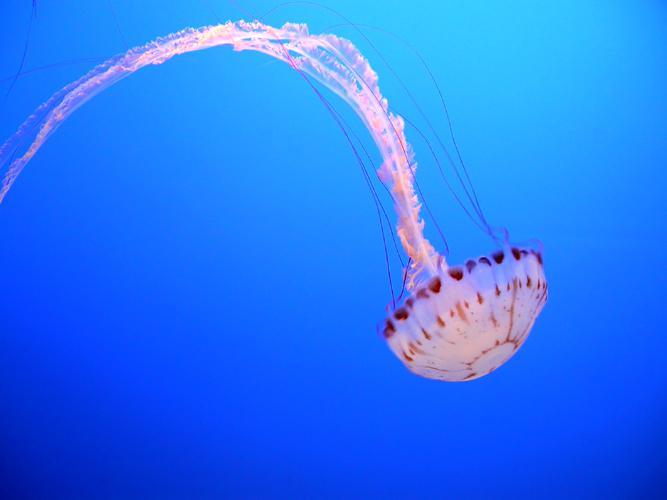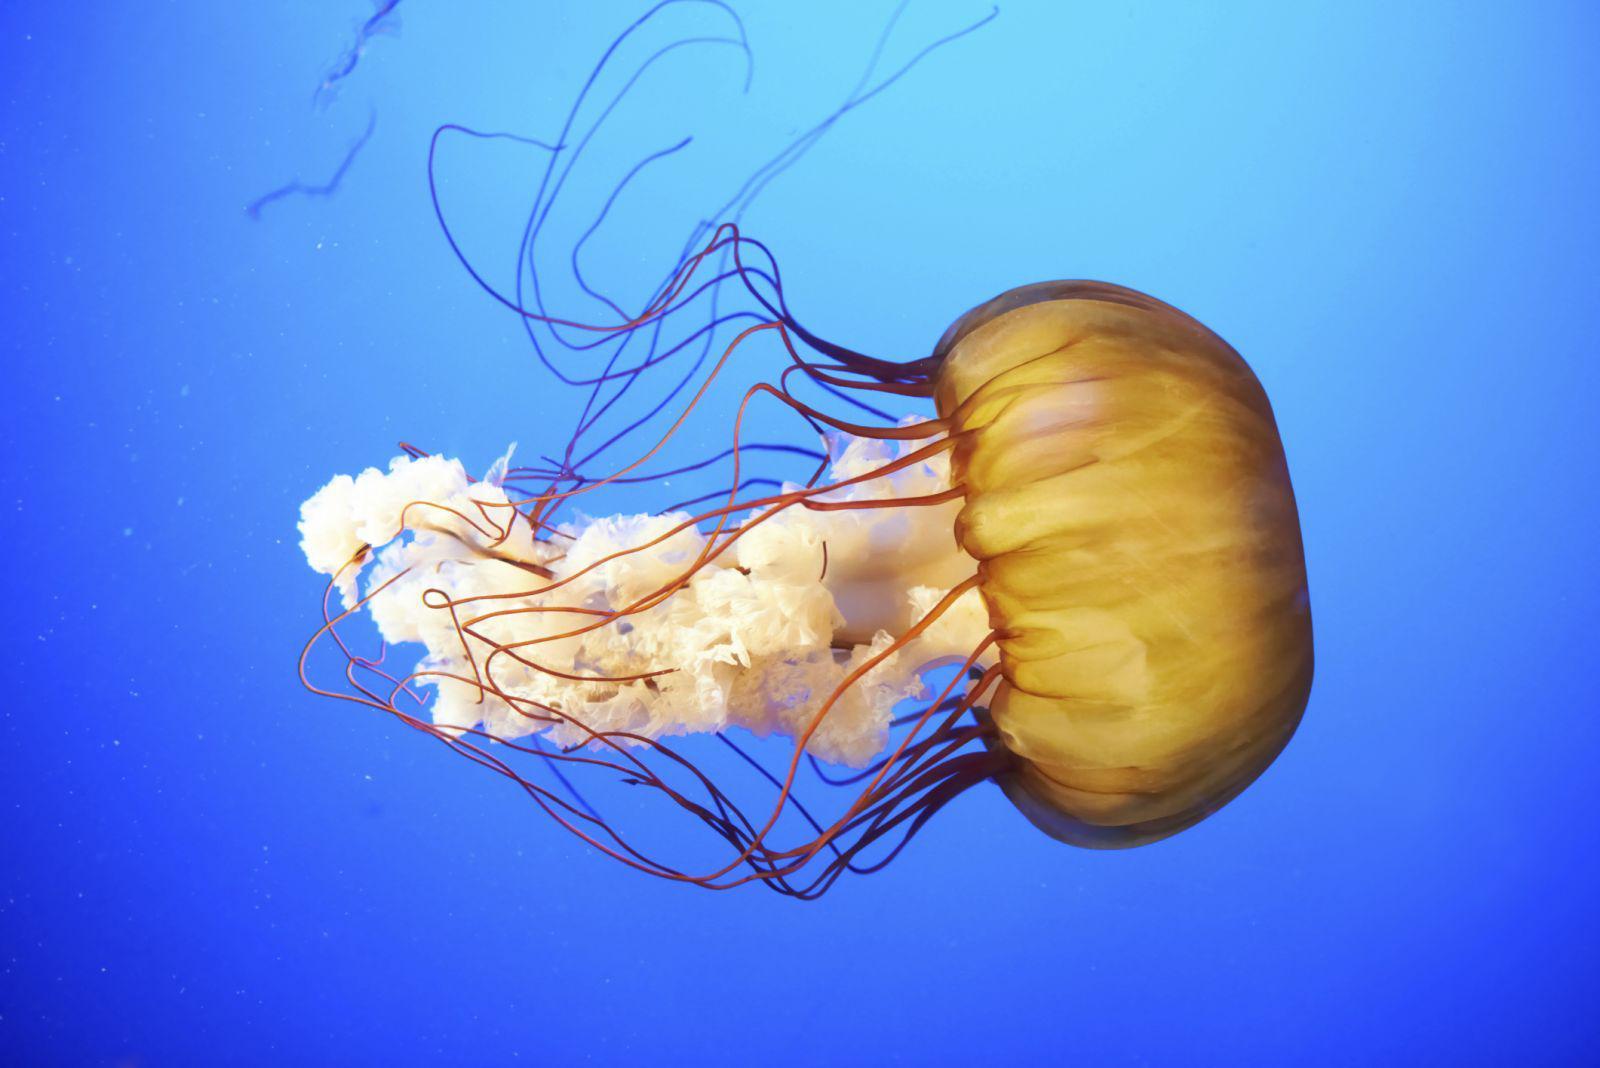The first image is the image on the left, the second image is the image on the right. For the images shown, is this caption "An image shows a human present with jellyfish." true? Answer yes or no. No. The first image is the image on the left, the second image is the image on the right. Given the left and right images, does the statement "A person is in one of the pictures." hold true? Answer yes or no. No. 